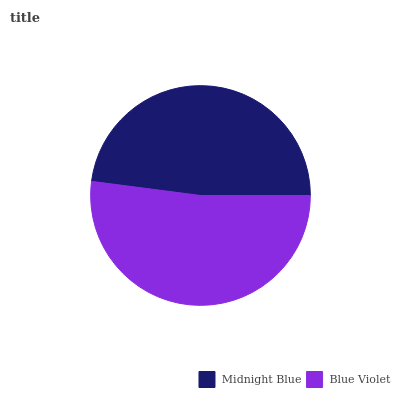Is Midnight Blue the minimum?
Answer yes or no. Yes. Is Blue Violet the maximum?
Answer yes or no. Yes. Is Blue Violet the minimum?
Answer yes or no. No. Is Blue Violet greater than Midnight Blue?
Answer yes or no. Yes. Is Midnight Blue less than Blue Violet?
Answer yes or no. Yes. Is Midnight Blue greater than Blue Violet?
Answer yes or no. No. Is Blue Violet less than Midnight Blue?
Answer yes or no. No. Is Blue Violet the high median?
Answer yes or no. Yes. Is Midnight Blue the low median?
Answer yes or no. Yes. Is Midnight Blue the high median?
Answer yes or no. No. Is Blue Violet the low median?
Answer yes or no. No. 